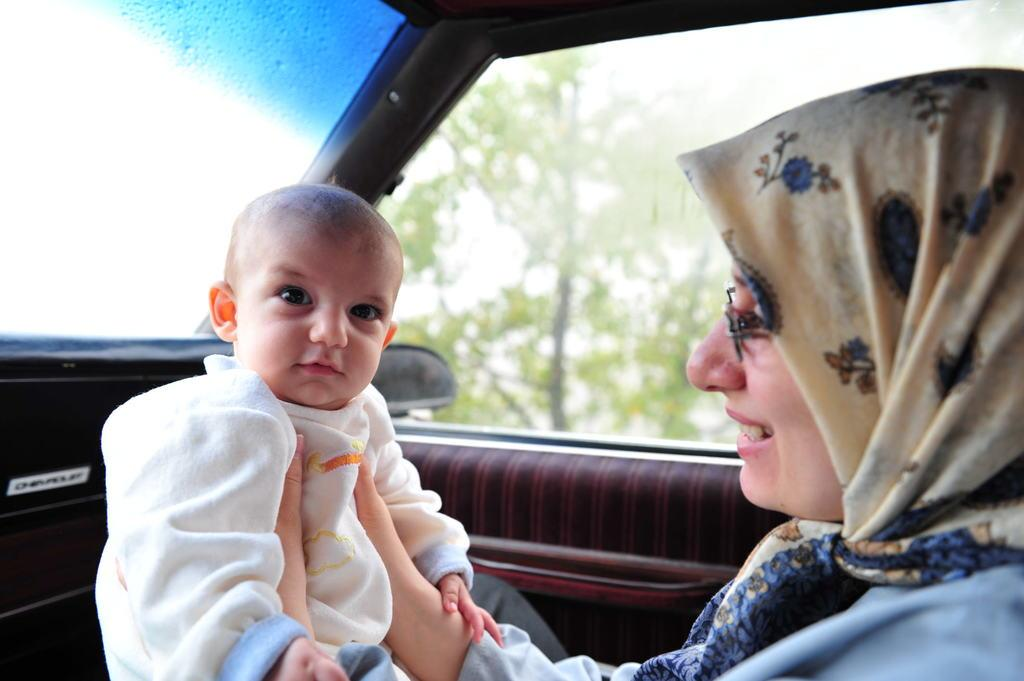Where was the image taken? The image was taken inside a car. Who is present in the image? There is a woman seated on the left side of the car. What is the woman doing in the image? The woman is smiling and holding a baby. What can be seen in the background of the image? There is a tree visible in the background. What is the position of the car window in relation to the woman? There is a car window on the left side. What type of butter is being spread on the songs in the image? There is no butter or songs present in the image; it features a woman seated in a car, smiling and holding a baby. What kind of board is being used to play games in the image? There is no board or game-playing activity present in the image. 